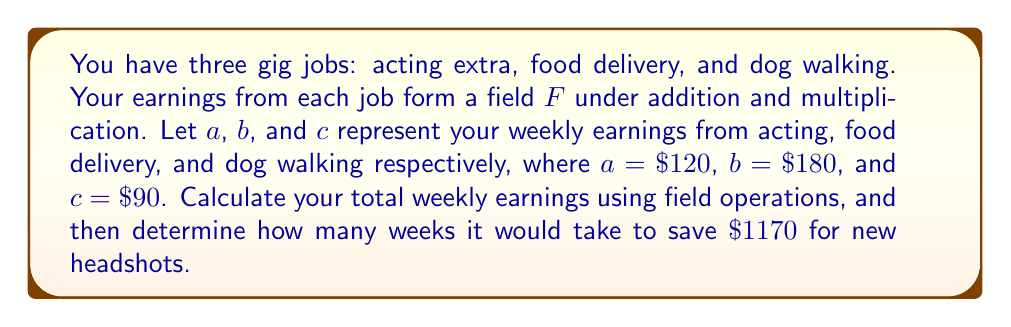Solve this math problem. 1. First, we need to calculate the total weekly earnings using field addition:
   $$t = a + b + c$$
   $$t = \$120 + \$180 + \$90 = \$390$$

2. To find how many weeks it takes to save $\$1170$, we need to use field division:
   $$w = \frac{\$1170}{t}$$
   $$w = \frac{\$1170}{\$390} = 3$$

3. We can verify this result using field multiplication:
   $$3 \cdot t = 3 \cdot \$390 = \$1170$$

Therefore, it would take 3 weeks to save $\$1170$ for new headshots.
Answer: 3 weeks 